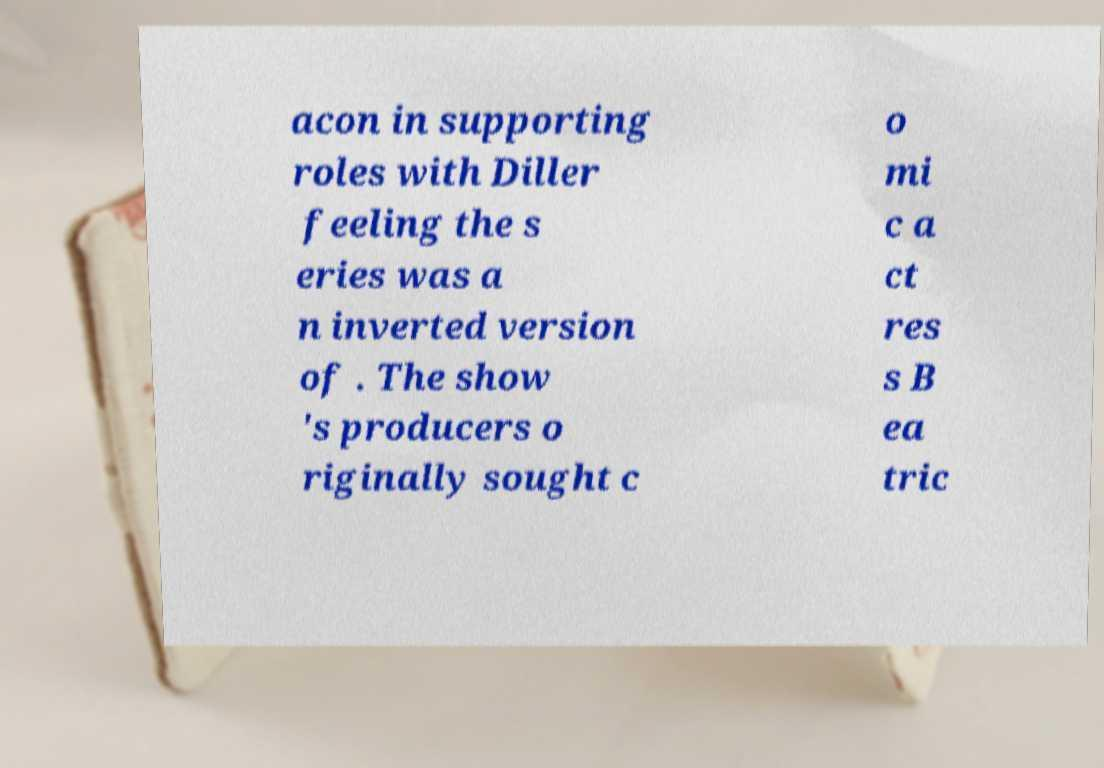Could you assist in decoding the text presented in this image and type it out clearly? acon in supporting roles with Diller feeling the s eries was a n inverted version of . The show 's producers o riginally sought c o mi c a ct res s B ea tric 